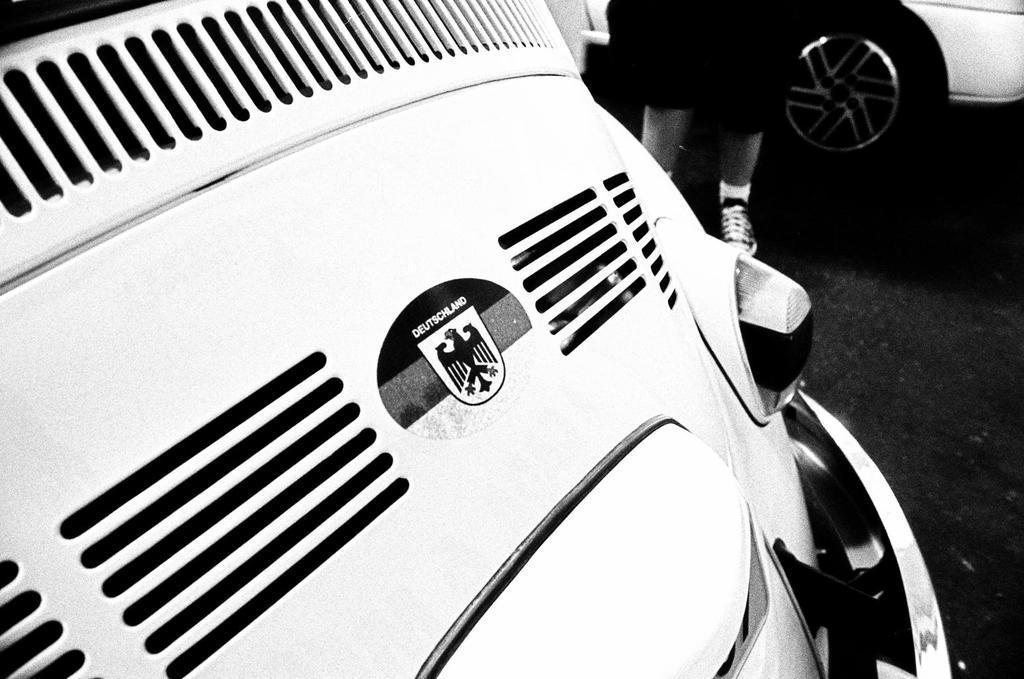Describe this image in one or two sentences. This is a black and white image. In this image, we can see the front side of the car. On the right side, we can see the legs of a person which are covered with shoes. On the right side, we can also see another car which is placed on the road. 